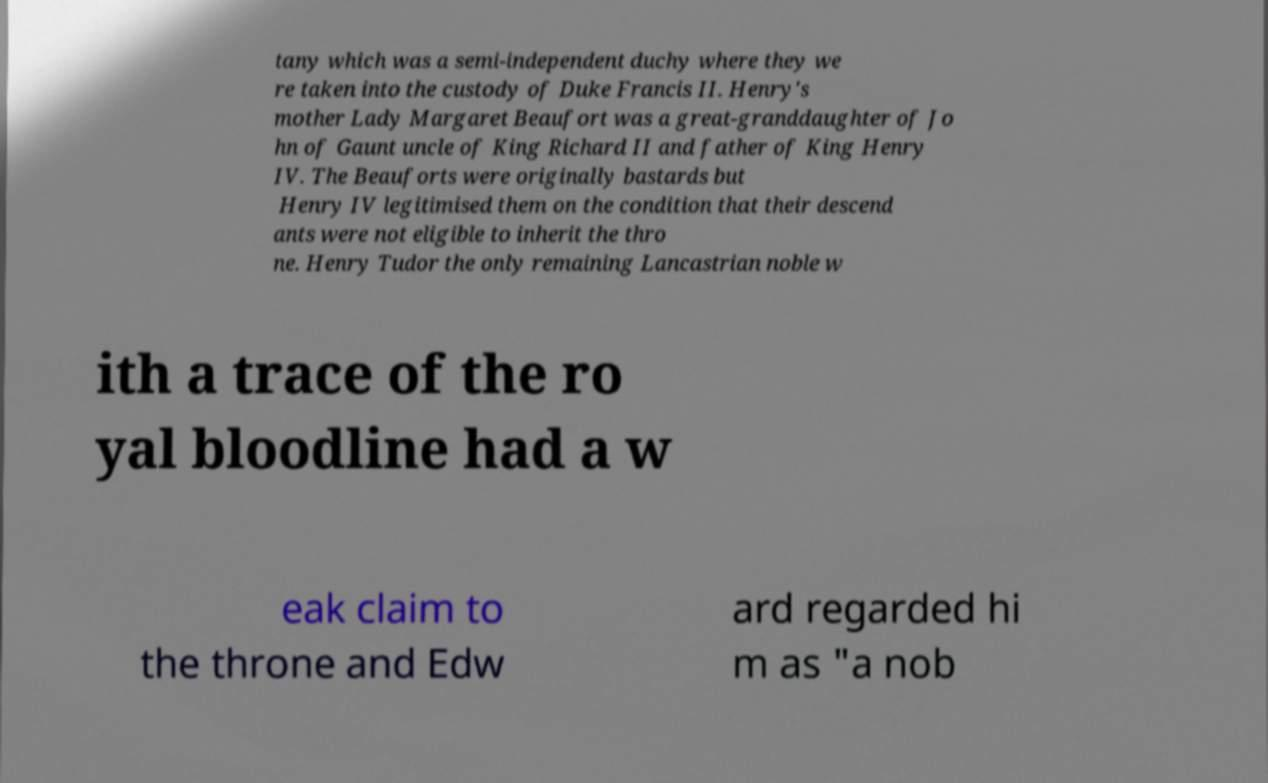Could you assist in decoding the text presented in this image and type it out clearly? tany which was a semi-independent duchy where they we re taken into the custody of Duke Francis II. Henry's mother Lady Margaret Beaufort was a great-granddaughter of Jo hn of Gaunt uncle of King Richard II and father of King Henry IV. The Beauforts were originally bastards but Henry IV legitimised them on the condition that their descend ants were not eligible to inherit the thro ne. Henry Tudor the only remaining Lancastrian noble w ith a trace of the ro yal bloodline had a w eak claim to the throne and Edw ard regarded hi m as "a nob 